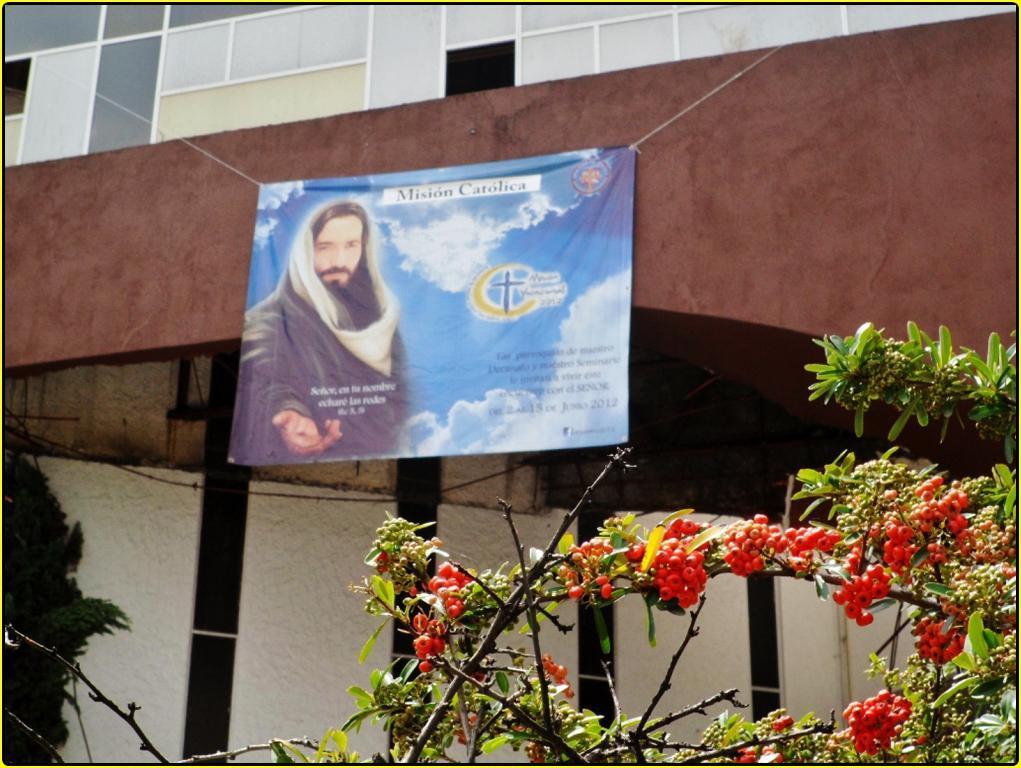Could you give a brief overview of what you see in this image? There is a tree which has red color objects on it in the right corner and there is a banner which has a picture and something written on it is tightened to a rope on either sides of it. 